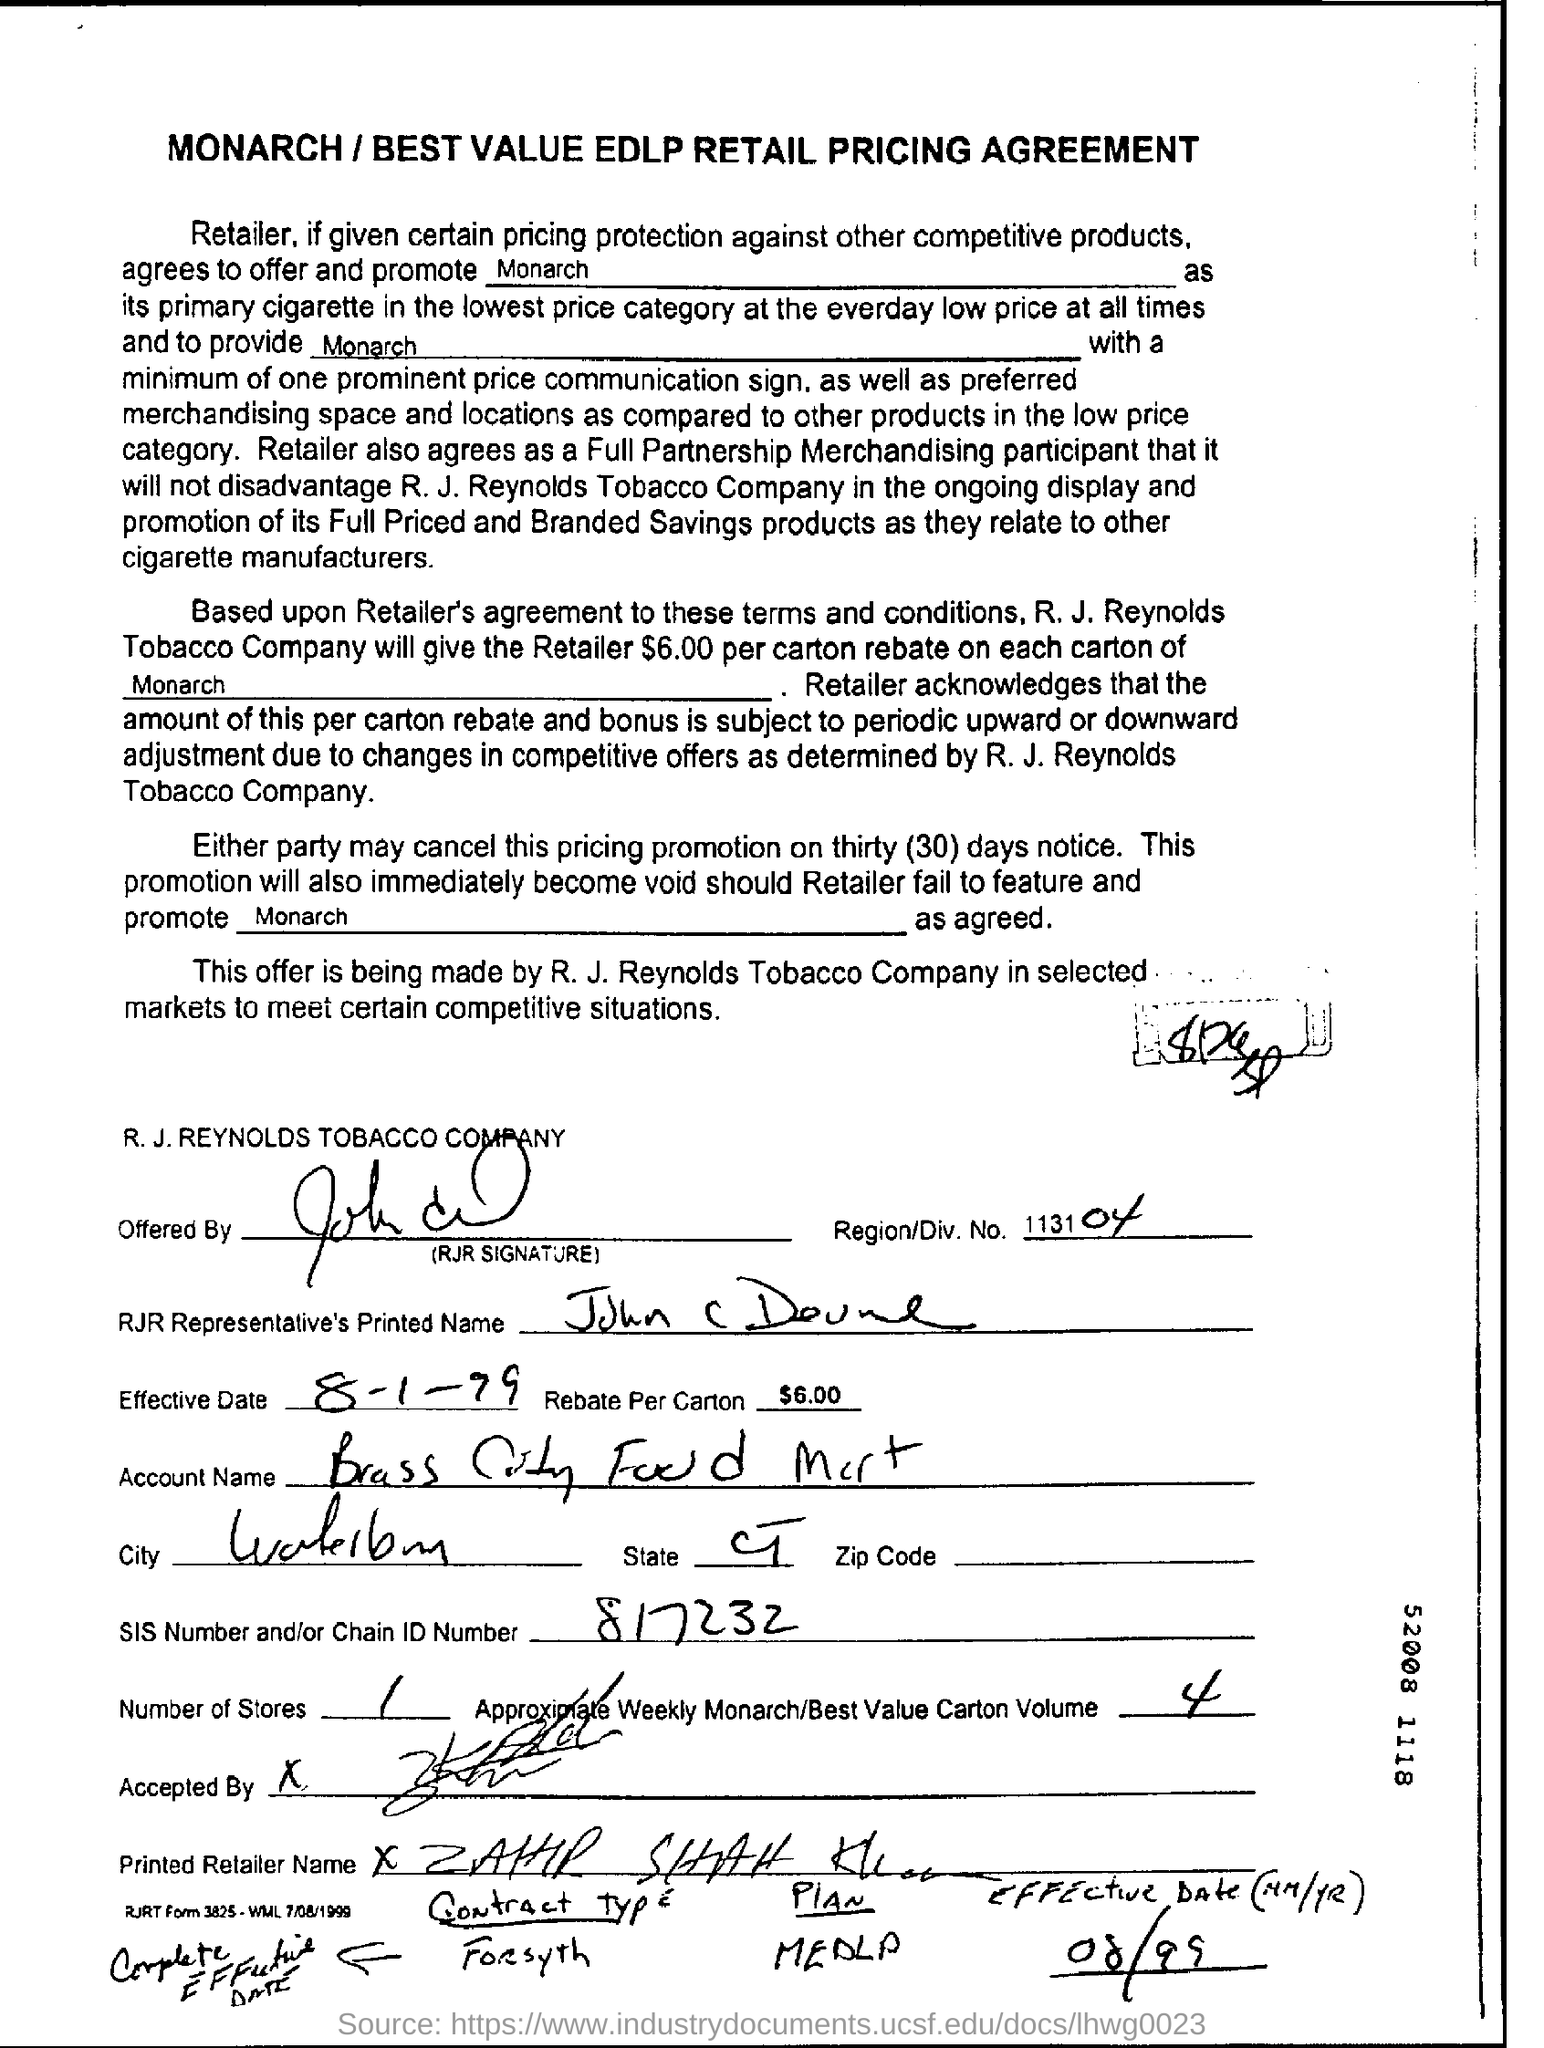What is the heading of this document?
Provide a succinct answer. MONARCH / BEST VALUE EDLP RETAIL PRICING AGREEMENT. What is the Company Name ?
Your answer should be very brief. R. J. REYNOLDS. What is the Effective Date  ?
Ensure brevity in your answer.  8-1-99. What is the Chain Id Number ?
Your answer should be very brief. 817232. How many stores are there ?
Ensure brevity in your answer.  1. What is the Region Number ?
Provide a short and direct response. 113104. What is written in the Rebate Per Carton Field ?
Your answer should be very brief. $6.00 per carton. 